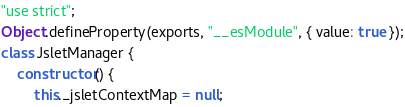<code> <loc_0><loc_0><loc_500><loc_500><_JavaScript_>"use strict";
Object.defineProperty(exports, "__esModule", { value: true });
class JsletManager {
    constructor() {
        this._jsletContextMap = null;</code> 